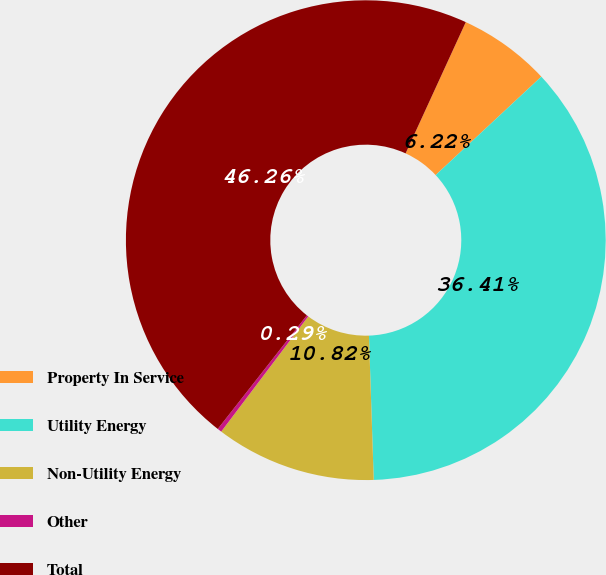Convert chart. <chart><loc_0><loc_0><loc_500><loc_500><pie_chart><fcel>Property In Service<fcel>Utility Energy<fcel>Non-Utility Energy<fcel>Other<fcel>Total<nl><fcel>6.22%<fcel>36.41%<fcel>10.82%<fcel>0.29%<fcel>46.26%<nl></chart> 